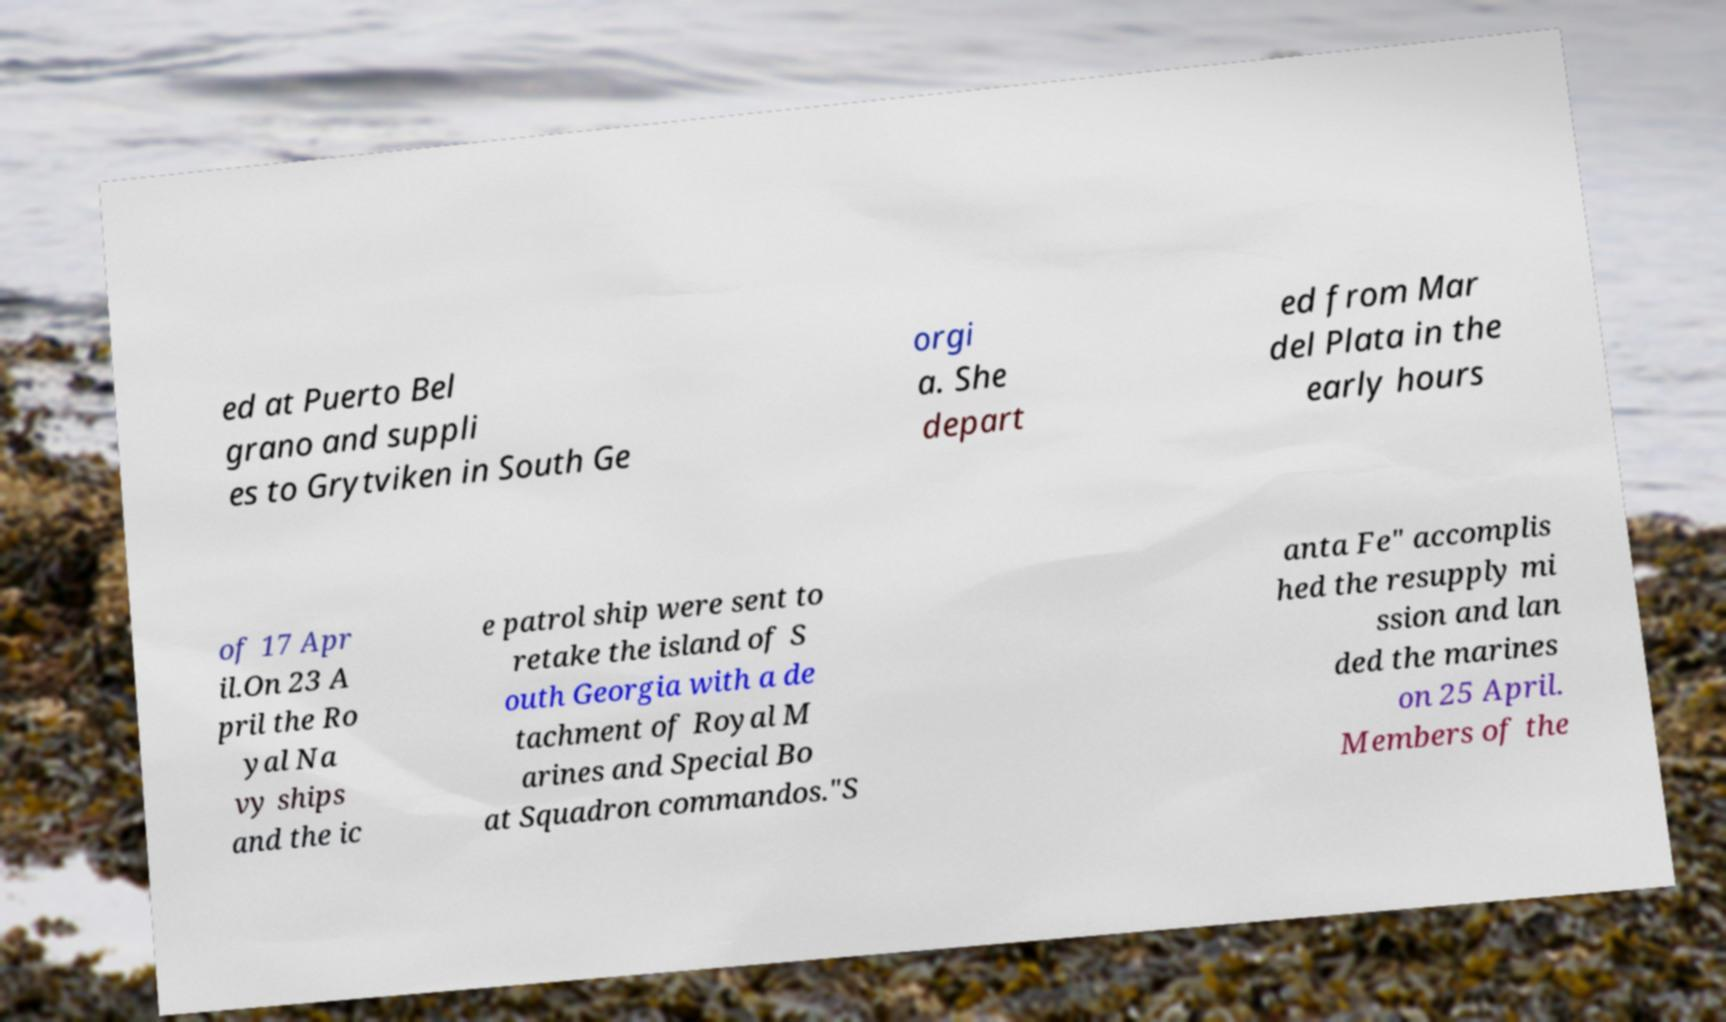Could you extract and type out the text from this image? ed at Puerto Bel grano and suppli es to Grytviken in South Ge orgi a. She depart ed from Mar del Plata in the early hours of 17 Apr il.On 23 A pril the Ro yal Na vy ships and the ic e patrol ship were sent to retake the island of S outh Georgia with a de tachment of Royal M arines and Special Bo at Squadron commandos."S anta Fe" accomplis hed the resupply mi ssion and lan ded the marines on 25 April. Members of the 